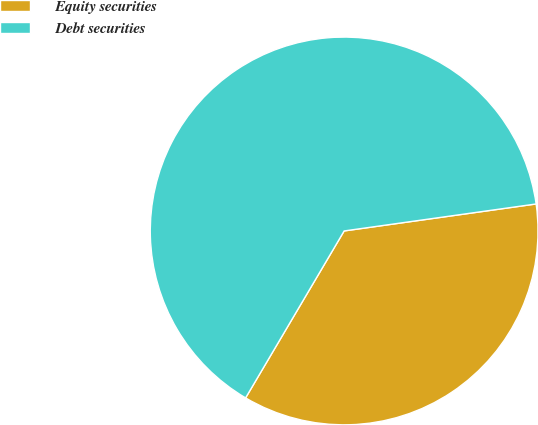<chart> <loc_0><loc_0><loc_500><loc_500><pie_chart><fcel>Equity securities<fcel>Debt securities<nl><fcel>35.71%<fcel>64.29%<nl></chart> 